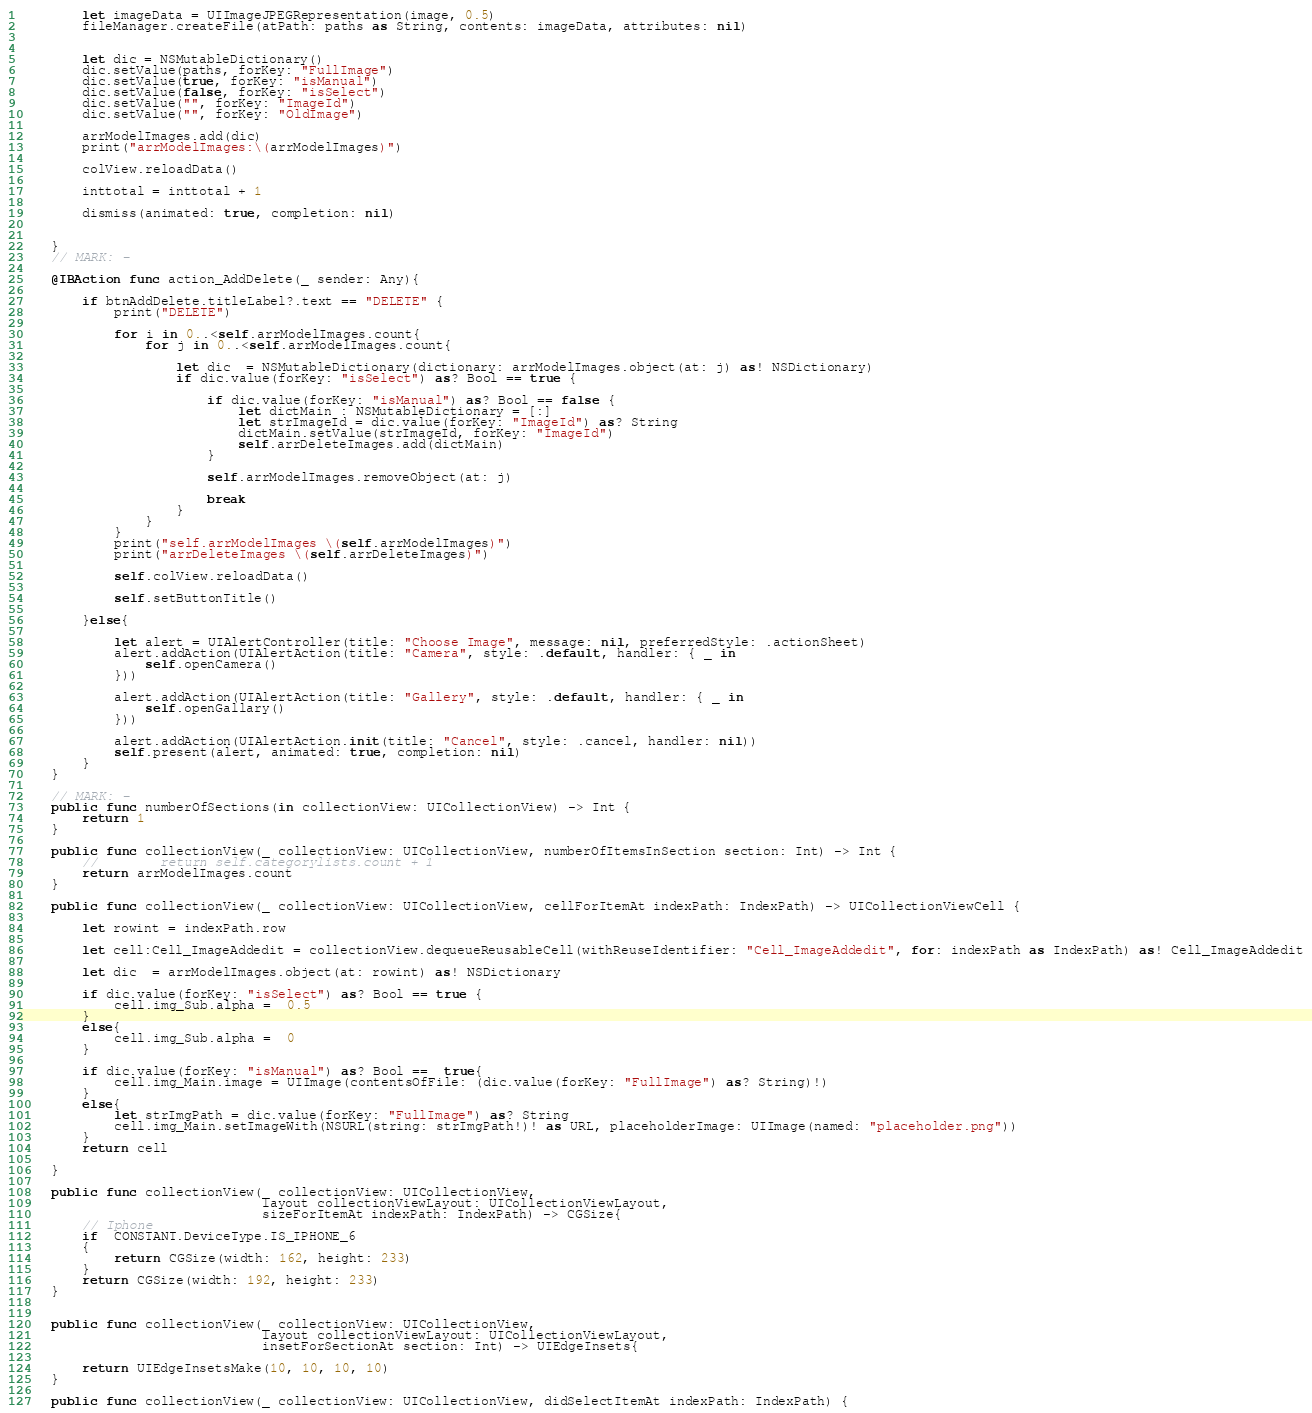<code> <loc_0><loc_0><loc_500><loc_500><_Swift_>        let imageData = UIImageJPEGRepresentation(image, 0.5)
        fileManager.createFile(atPath: paths as String, contents: imageData, attributes: nil)
        
        
        let dic = NSMutableDictionary()
        dic.setValue(paths, forKey: "FullImage")
        dic.setValue(true, forKey: "isManual")
        dic.setValue(false, forKey: "isSelect")
        dic.setValue("", forKey: "ImageId")
        dic.setValue("", forKey: "OldImage")
        
        arrModelImages.add(dic)
        print("arrModelImages:\(arrModelImages)")
        
        colView.reloadData()
        
        inttotal = inttotal + 1
        
        dismiss(animated: true, completion: nil)
        
        
    }
    // MARK: -
    
    @IBAction func action_AddDelete(_ sender: Any){
        
        if btnAddDelete.titleLabel?.text == "DELETE" {
            print("DELETE")
            
            for i in 0..<self.arrModelImages.count{
                for j in 0..<self.arrModelImages.count{
                    
                    let dic  = NSMutableDictionary(dictionary: arrModelImages.object(at: j) as! NSDictionary)
                    if dic.value(forKey: "isSelect") as? Bool == true {
                        
                        if dic.value(forKey: "isManual") as? Bool == false {
                            let dictMain : NSMutableDictionary = [:]
                            let strImageId = dic.value(forKey: "ImageId") as? String
                            dictMain.setValue(strImageId, forKey: "ImageId")
                            self.arrDeleteImages.add(dictMain)
                        }
                        
                        self.arrModelImages.removeObject(at: j)
                        
                        break
                    }
                }
            }
            print("self.arrModelImages \(self.arrModelImages)")
            print("arrDeleteImages \(self.arrDeleteImages)")
            
            self.colView.reloadData()
            
            self.setButtonTitle()
            
        }else{
            
            let alert = UIAlertController(title: "Choose Image", message: nil, preferredStyle: .actionSheet)
            alert.addAction(UIAlertAction(title: "Camera", style: .default, handler: { _ in
                self.openCamera()
            }))
            
            alert.addAction(UIAlertAction(title: "Gallery", style: .default, handler: { _ in
                self.openGallary()
            }))
            
            alert.addAction(UIAlertAction.init(title: "Cancel", style: .cancel, handler: nil))
            self.present(alert, animated: true, completion: nil)
        }
    }

    // MARK: -
    public func numberOfSections(in collectionView: UICollectionView) -> Int {
        return 1
    }
    
    public func collectionView(_ collectionView: UICollectionView, numberOfItemsInSection section: Int) -> Int {
        //        return self.categorylists.count + 1
        return arrModelImages.count
    }
    
    public func collectionView(_ collectionView: UICollectionView, cellForItemAt indexPath: IndexPath) -> UICollectionViewCell {
        
        let rowint = indexPath.row
        
        let cell:Cell_ImageAddedit = collectionView.dequeueReusableCell(withReuseIdentifier: "Cell_ImageAddedit", for: indexPath as IndexPath) as! Cell_ImageAddedit
        
        let dic  = arrModelImages.object(at: rowint) as! NSDictionary
        
        if dic.value(forKey: "isSelect") as? Bool == true {
            cell.img_Sub.alpha =  0.5
        }
        else{
            cell.img_Sub.alpha =  0
        }
        
        if dic.value(forKey: "isManual") as? Bool ==  true{
            cell.img_Main.image = UIImage(contentsOfFile: (dic.value(forKey: "FullImage") as? String)!)
        }
        else{
            let strImgPath = dic.value(forKey: "FullImage") as? String
            cell.img_Main.setImageWith(NSURL(string: strImgPath!)! as URL, placeholderImage: UIImage(named: "placeholder.png"))
        }
        return cell
        
    }
    
    public func collectionView(_ collectionView: UICollectionView,
                               layout collectionViewLayout: UICollectionViewLayout,
                               sizeForItemAt indexPath: IndexPath) -> CGSize{
        // Iphone
        if  CONSTANT.DeviceType.IS_IPHONE_6
        {
            return CGSize(width: 162, height: 233)
        }
        return CGSize(width: 192, height: 233)
    }
    
    
    public func collectionView(_ collectionView: UICollectionView,
                               layout collectionViewLayout: UICollectionViewLayout,
                               insetForSectionAt section: Int) -> UIEdgeInsets{
        
        return UIEdgeInsetsMake(10, 10, 10, 10)
    }
    
    public func collectionView(_ collectionView: UICollectionView, didSelectItemAt indexPath: IndexPath) {</code> 